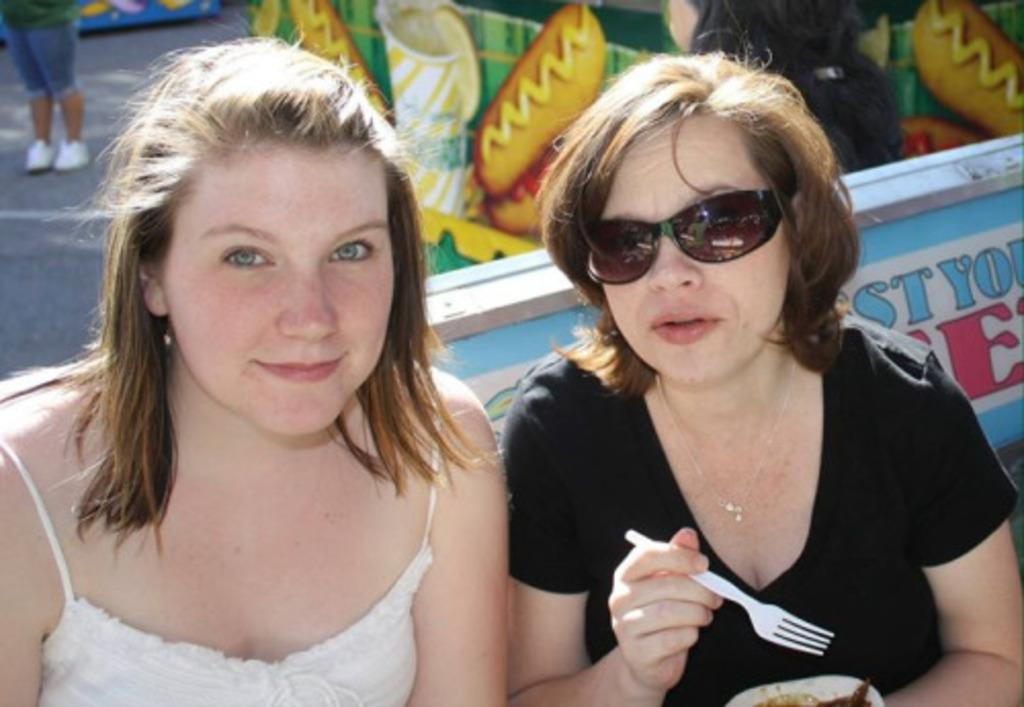How many people are in the image? There are people in the image, but the exact number is not specified. What are the people wearing? The people in the image are wearing clothes. Can you describe the person on the right side of the image? The person on the right side of the image is holding a fork. What can be seen in the middle of the image? There are boards in the middle of the image. How many rings are visible on the person's fingers in the image? There is no mention of rings in the image, so we cannot determine the number of rings visible on the person's fingers. 